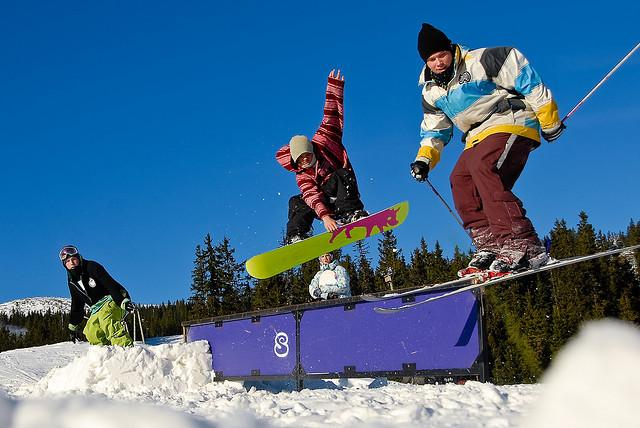What is the black hat the man is wearing called? Please explain your reasoning. beanie. The man has a beanie on. 